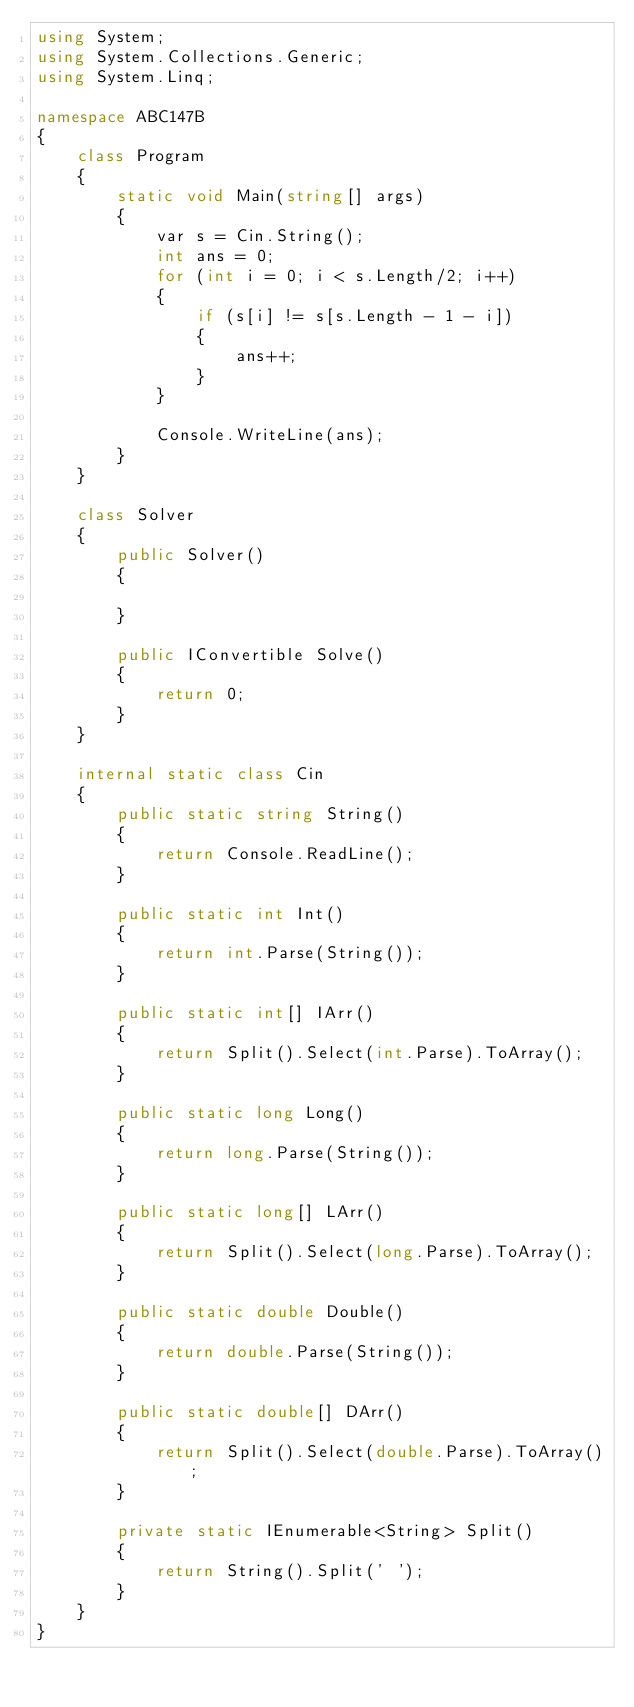<code> <loc_0><loc_0><loc_500><loc_500><_C#_>using System;
using System.Collections.Generic;
using System.Linq;

namespace ABC147B
{
    class Program
    {
        static void Main(string[] args)
        {
            var s = Cin.String();
            int ans = 0;
            for (int i = 0; i < s.Length/2; i++)
            {
                if (s[i] != s[s.Length - 1 - i])
                {
                    ans++;
                }
            }
            
            Console.WriteLine(ans);
        }
    }

    class Solver
    {
        public Solver()
        {

        }

        public IConvertible Solve()
        {
            return 0;
        }
    }

    internal static class Cin
    {
        public static string String()
        {
            return Console.ReadLine();
        }

        public static int Int()
        {
            return int.Parse(String());
        }

        public static int[] IArr()
        {
            return Split().Select(int.Parse).ToArray();
        }

        public static long Long()
        {
            return long.Parse(String());
        }

        public static long[] LArr()
        {
            return Split().Select(long.Parse).ToArray();
        }

        public static double Double()
        {
            return double.Parse(String());
        }

        public static double[] DArr()
        {
            return Split().Select(double.Parse).ToArray();
        }

        private static IEnumerable<String> Split()
        {
            return String().Split(' ');
        }
    }
}</code> 